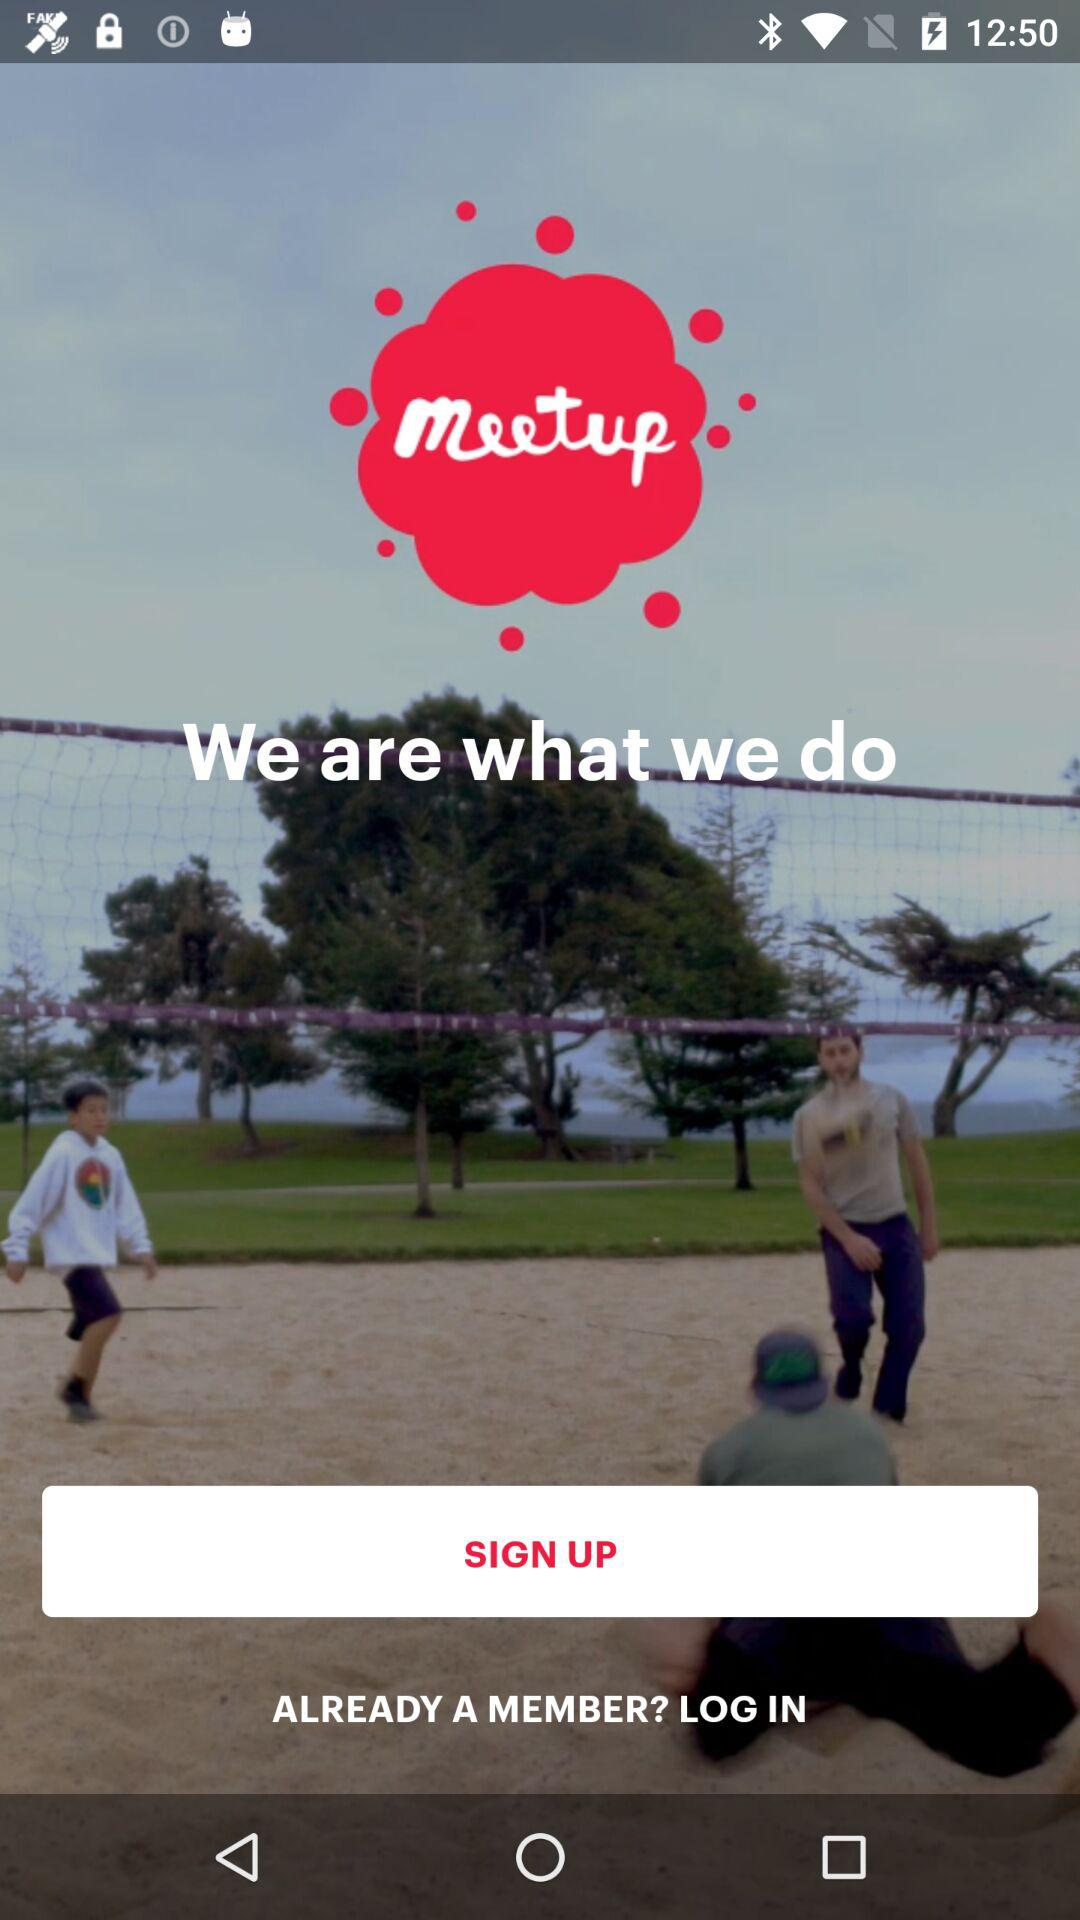What is the application name? The application name is "Meetup". 